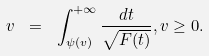<formula> <loc_0><loc_0><loc_500><loc_500>v \ = \ \int _ { \psi ( v ) } ^ { + \infty } \frac { d t } { \sqrt { F ( t ) } } , v \geq 0 .</formula> 